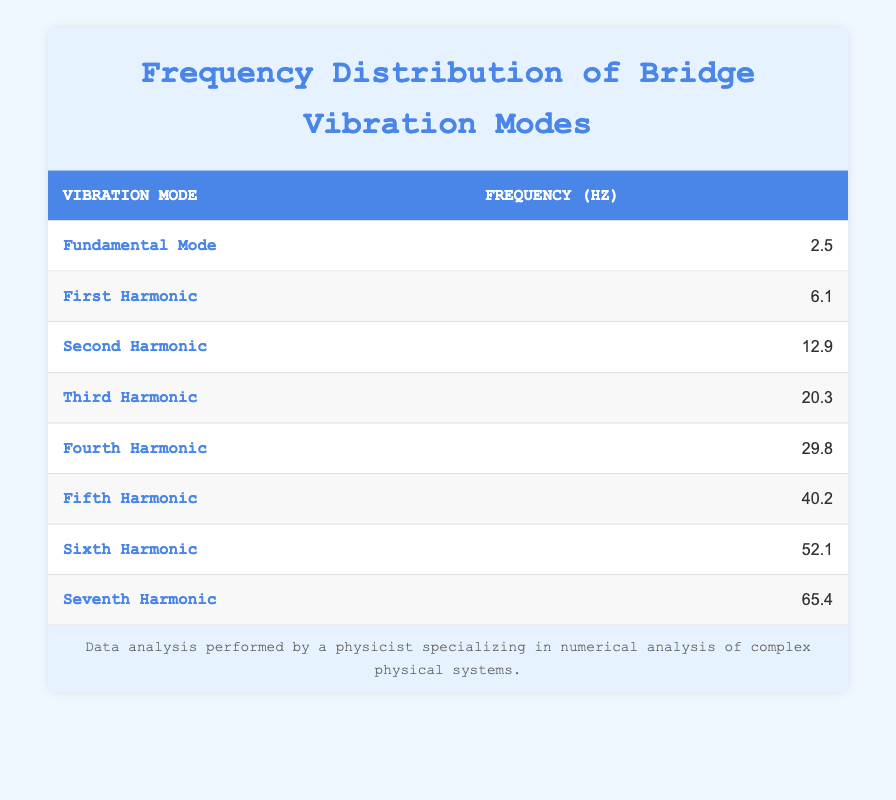What is the frequency of the Fundamental Mode? The Fundamental Mode is explicitly listed in the table with its frequency value. We can directly refer to that row and find that it is 2.5 Hz.
Answer: 2.5 Hz What is the frequency of the Seventh Harmonic? Based on the table, the frequency for the Seventh Harmonic is stated directly in its respective row, which is 65.4 Hz.
Answer: 65.4 Hz What is the average frequency of the First, Third, and Fifth Harmonics? To find the average, add the frequencies of the First Harmonic (6.1 Hz), Third Harmonic (20.3 Hz), and Fifth Harmonic (40.2 Hz): 6.1 + 20.3 + 40.2 = 66.6 Hz. There are three values, so divide by 3: 66.6 / 3 = 22.2 Hz.
Answer: 22.2 Hz Is the frequency of the Sixth Harmonic greater than that of the Fourth Harmonic? From the table, the frequency of the Sixth Harmonic is 52.1 Hz, while the Fourth Harmonic is 29.8 Hz. Since 52.1 is greater than 29.8, the statement is true.
Answer: Yes Which harmonic has the largest frequency value? To determine the largest frequency, we compare all values in the table. The frequencies listed are 2.5, 6.1, 12.9, 20.3, 29.8, 40.2, 52.1, and 65.4 Hz. The highest value among these is 65.4 Hz, which belongs to the Seventh Harmonic.
Answer: Seventh Harmonic What is the difference in frequency between the Fifth and Second Harmonics? The frequency of the Fifth Harmonic is 40.2 Hz and for the Second Harmonic is 12.9 Hz. To find the difference, subtract the Second Harmonic's frequency from the Fifth Harmonic's frequency: 40.2 - 12.9 = 27.3 Hz.
Answer: 27.3 Hz Is the frequency of the Third Harmonic less than 25 Hz? Looking at the table, the frequency of the Third Harmonic is 20.3 Hz. Since 20.3 is indeed less than 25, the answer to the question is true.
Answer: Yes Which mode has a frequency closest to 30 Hz? To find the mode closest to 30 Hz, we compare the frequencies: 29.8 Hz (Fourth Harmonic) is the closest to 30 Hz compared to other values. Therefore, the Fourth Harmonic fits this criterion best.
Answer: Fourth Harmonic 